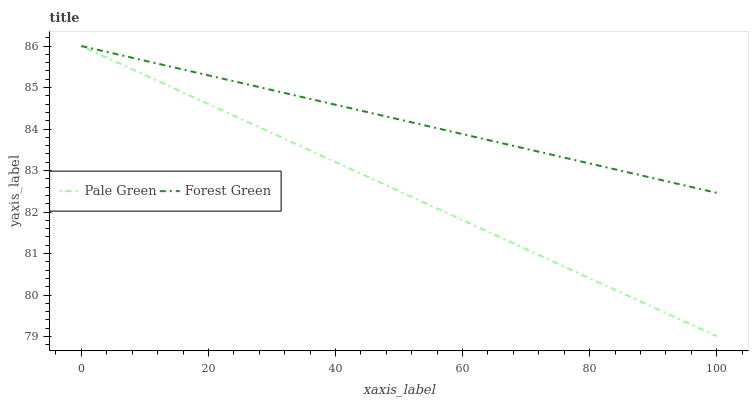Does Pale Green have the minimum area under the curve?
Answer yes or no. Yes. Does Forest Green have the maximum area under the curve?
Answer yes or no. Yes. Does Pale Green have the maximum area under the curve?
Answer yes or no. No. Is Pale Green the smoothest?
Answer yes or no. Yes. Is Forest Green the roughest?
Answer yes or no. Yes. Is Pale Green the roughest?
Answer yes or no. No. Does Pale Green have the lowest value?
Answer yes or no. Yes. Does Pale Green have the highest value?
Answer yes or no. Yes. Does Pale Green intersect Forest Green?
Answer yes or no. Yes. Is Pale Green less than Forest Green?
Answer yes or no. No. Is Pale Green greater than Forest Green?
Answer yes or no. No. 